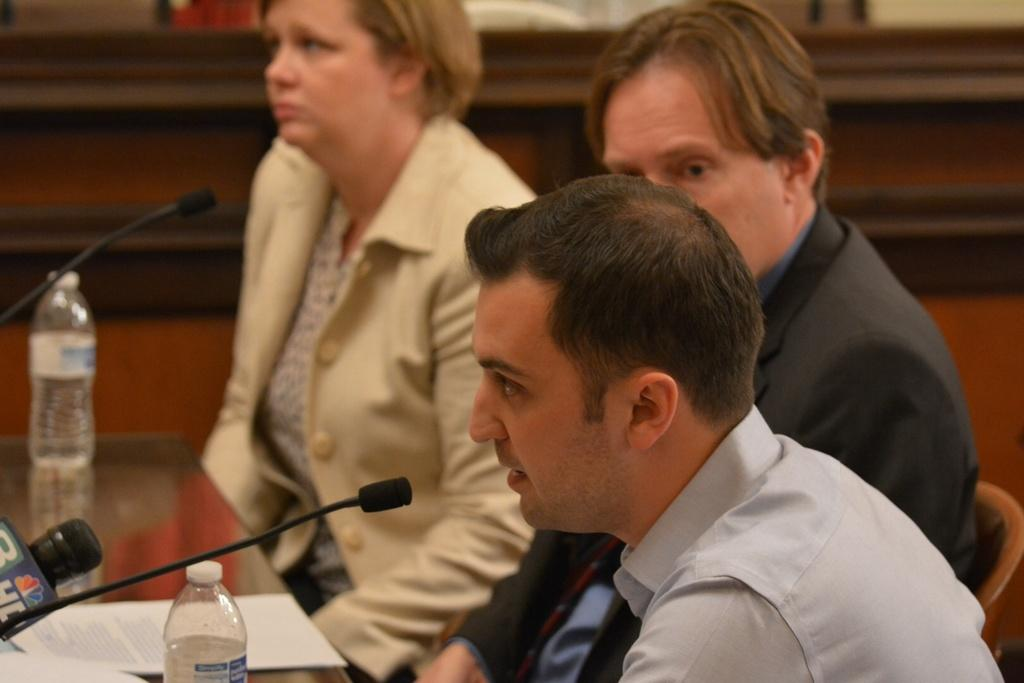What type of view is shown in the image? The image is an inside view. How many people are sitting in the image? There are three persons sitting on chairs. What are the chairs positioned in front of? The chairs are in front of a table. What items can be seen on the table? There are two bottles, papers, and a microphone on the table. What color is the stocking on the person's heart in the image? There is no stocking or heart visible in the image; it only shows three persons sitting on chairs, a table, and various items on the table. 